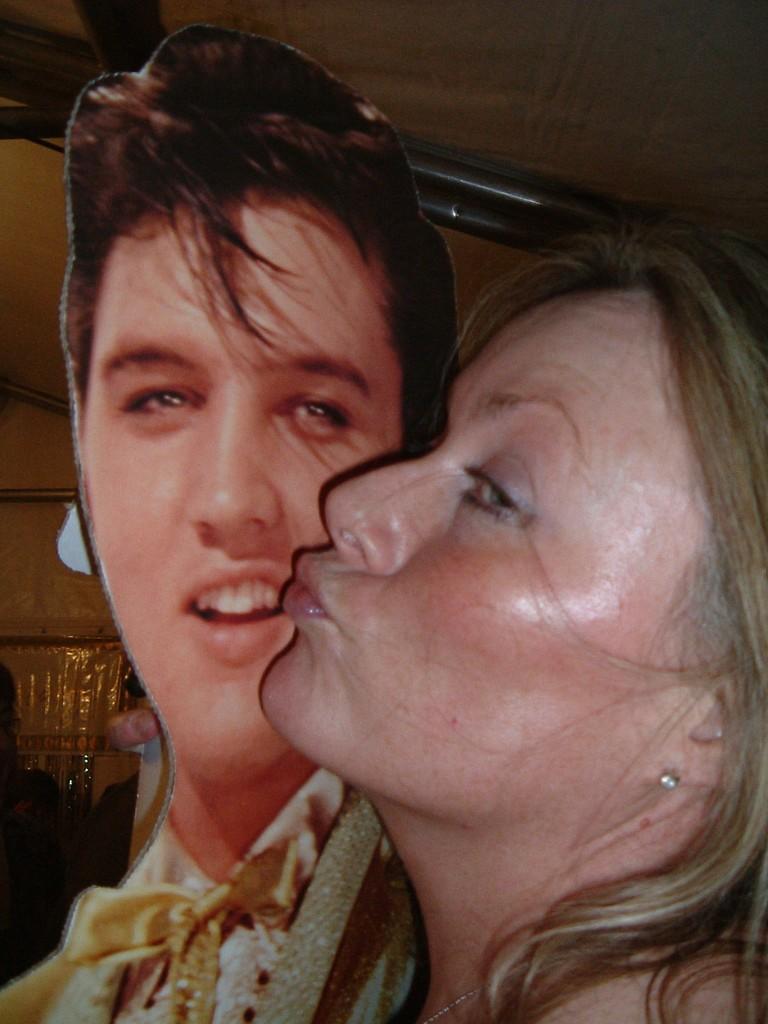Can you describe this image briefly? In this image we can see a woman holding a photo of a person. In the background we can see poles , 